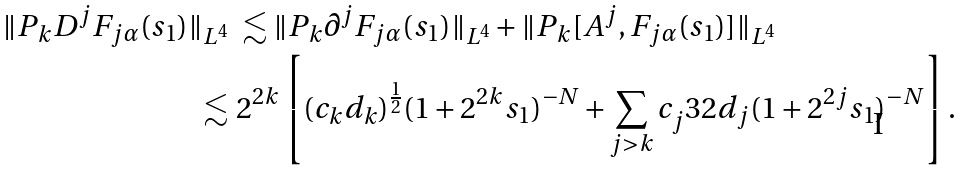Convert formula to latex. <formula><loc_0><loc_0><loc_500><loc_500>\| P _ { k } D ^ { j } F _ { j \alpha } ( s _ { 1 } ) \| _ { L ^ { 4 } } & \ \lesssim \| P _ { k } \partial ^ { j } F _ { j \alpha } ( s _ { 1 } ) \| _ { L ^ { 4 } } + \| P _ { k } [ A ^ { j } , F _ { j \alpha } ( s _ { 1 } ) ] \| _ { L ^ { 4 } } \\ \lesssim & \ 2 ^ { 2 k } \left [ ( c _ { k } d _ { k } ) ^ { \frac { 1 } { 2 } } ( 1 + 2 ^ { 2 k } s _ { 1 } ) ^ { - N } + \sum _ { j > k } c _ { j } ^ { } { 3 } 2 d _ { j } ( 1 + 2 ^ { 2 j } s _ { 1 } ) ^ { - N } \right ] .</formula> 